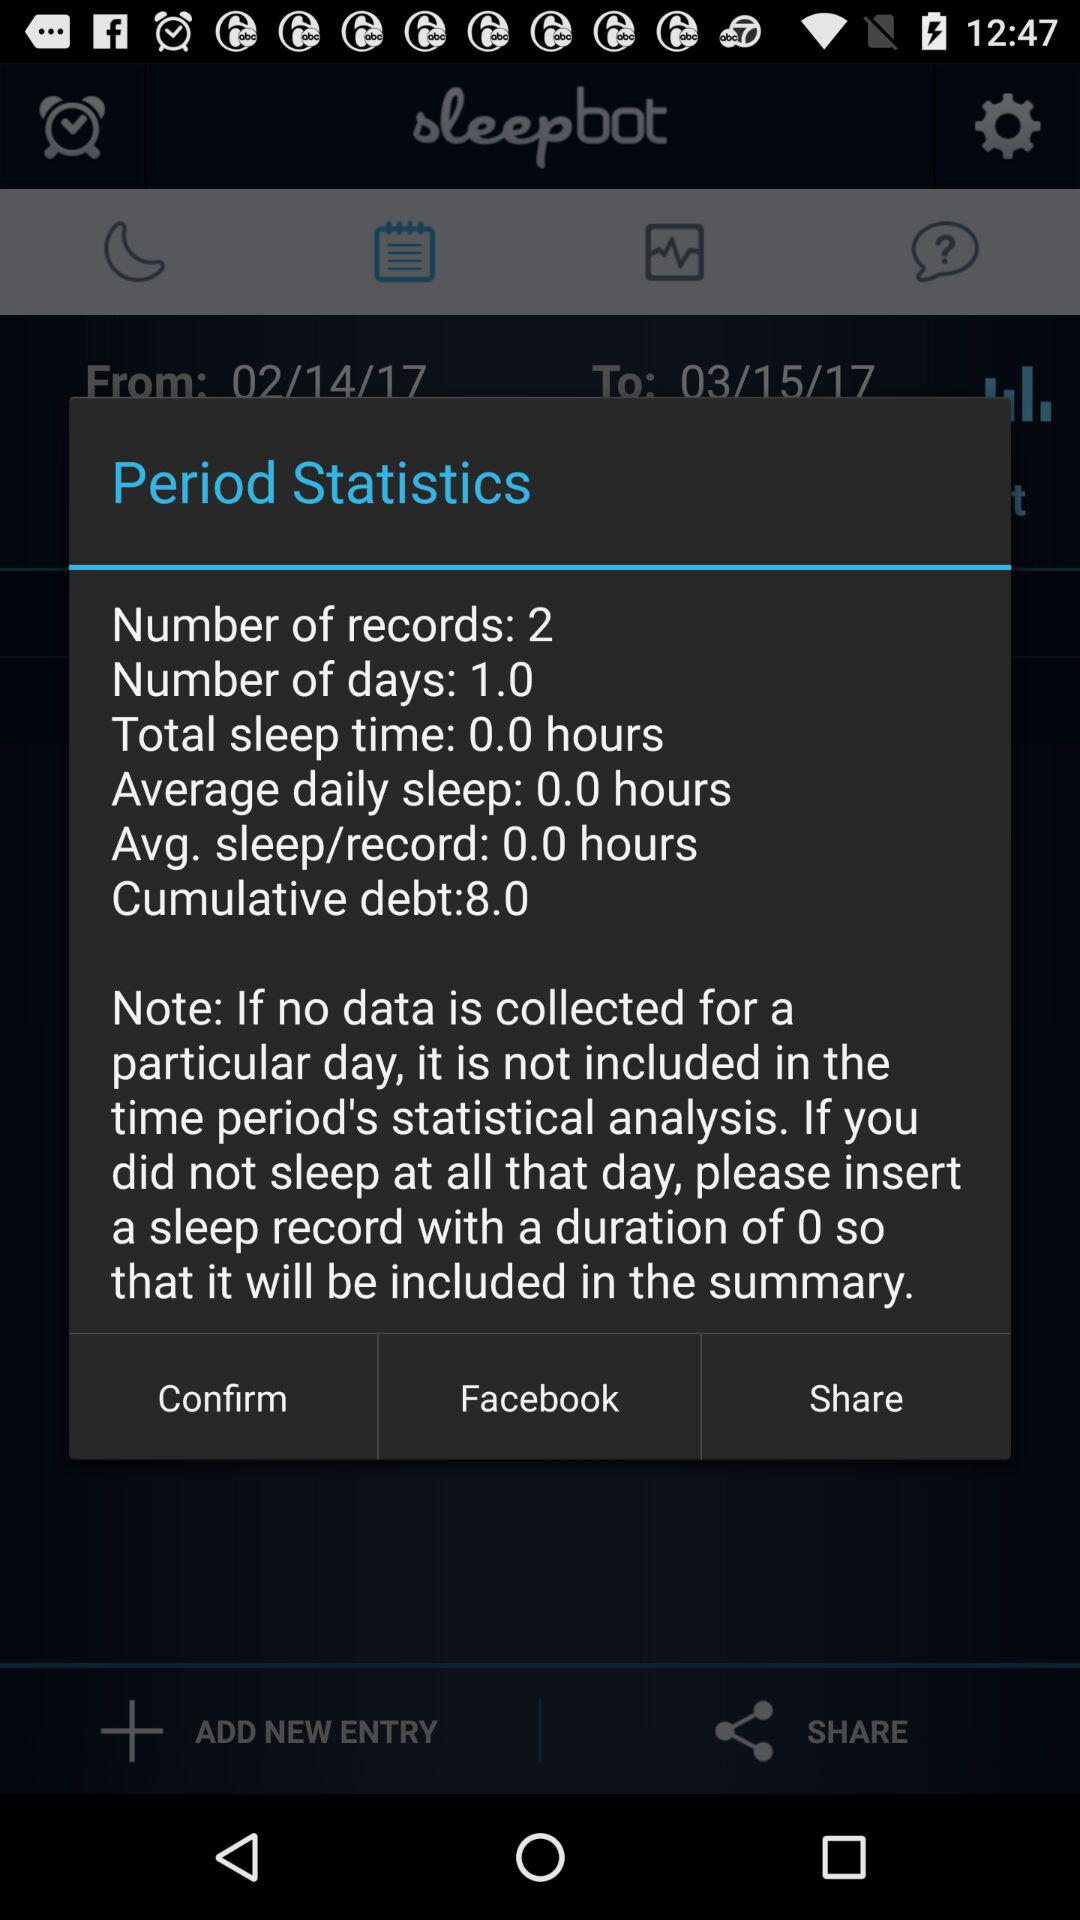What is the average sleep duration for each record?
Answer the question using a single word or phrase. 0.0 hours 